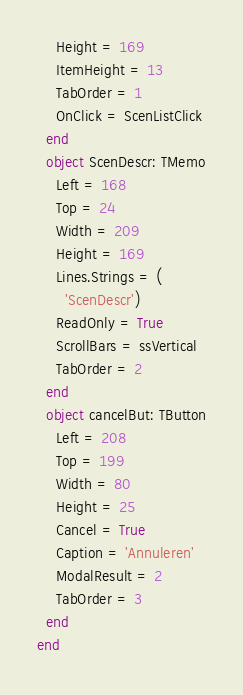<code> <loc_0><loc_0><loc_500><loc_500><_Pascal_>    Height = 169
    ItemHeight = 13
    TabOrder = 1
    OnClick = ScenListClick
  end
  object ScenDescr: TMemo
    Left = 168
    Top = 24
    Width = 209
    Height = 169
    Lines.Strings = (
      'ScenDescr')
    ReadOnly = True
    ScrollBars = ssVertical
    TabOrder = 2
  end
  object cancelBut: TButton
    Left = 208
    Top = 199
    Width = 80
    Height = 25
    Cancel = True
    Caption = 'Annuleren'
    ModalResult = 2
    TabOrder = 3
  end
end
</code> 